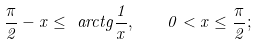<formula> <loc_0><loc_0><loc_500><loc_500>\frac { \pi } { 2 } - x \leq \ a r c t g \frac { 1 } { x } , \quad 0 < x \leq \frac { \pi } { 2 } ;</formula> 